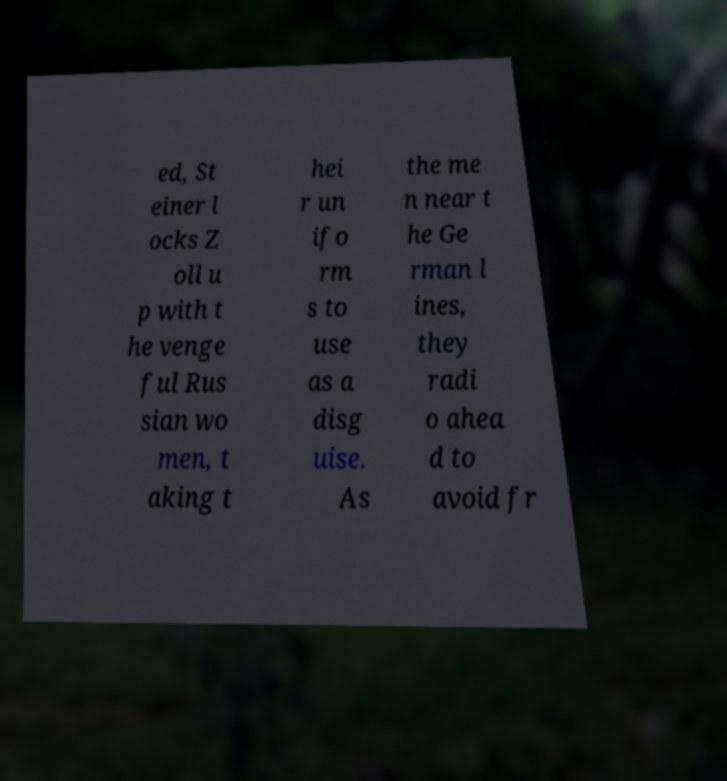Please read and relay the text visible in this image. What does it say? ed, St einer l ocks Z oll u p with t he venge ful Rus sian wo men, t aking t hei r un ifo rm s to use as a disg uise. As the me n near t he Ge rman l ines, they radi o ahea d to avoid fr 